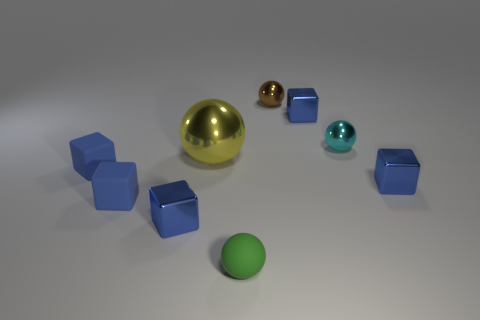Subtract all gray blocks. Subtract all blue cylinders. How many blocks are left? 5 Subtract all spheres. How many objects are left? 5 Add 6 large shiny objects. How many large shiny objects are left? 7 Add 5 large gray metal objects. How many large gray metal objects exist? 5 Subtract 0 green cylinders. How many objects are left? 9 Subtract all green spheres. Subtract all tiny blue matte cubes. How many objects are left? 6 